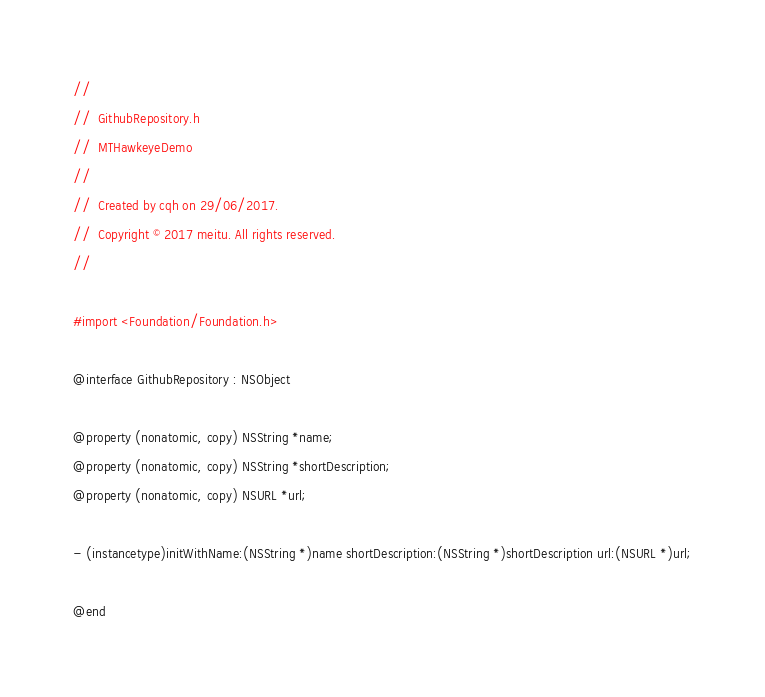<code> <loc_0><loc_0><loc_500><loc_500><_C_>//
//  GithubRepository.h
//  MTHawkeyeDemo
//
//  Created by cqh on 29/06/2017.
//  Copyright © 2017 meitu. All rights reserved.
//

#import <Foundation/Foundation.h>

@interface GithubRepository : NSObject

@property (nonatomic, copy) NSString *name;
@property (nonatomic, copy) NSString *shortDescription;
@property (nonatomic, copy) NSURL *url;

- (instancetype)initWithName:(NSString *)name shortDescription:(NSString *)shortDescription url:(NSURL *)url;

@end
</code> 